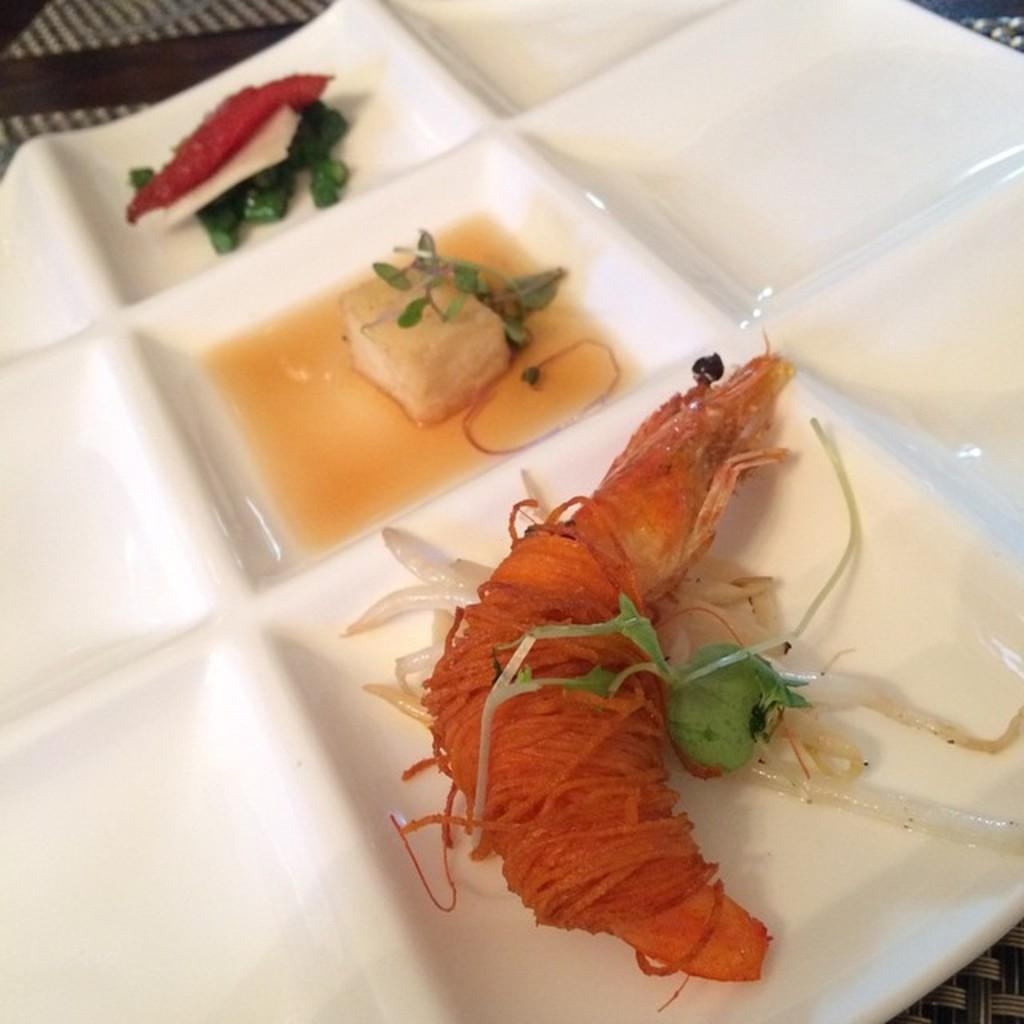What is present on the plate in the image? There are food items on the plate in the image. Can you describe the food items on the plate? Unfortunately, the specific food items cannot be determined from the provided facts. Is there any cutlery or utensils visible in the image? The provided facts do not mention any cutlery or utensils. Is there a girl sitting on the cloud in the image? There is no girl or cloud present in the image; it only features a plate with food items. 